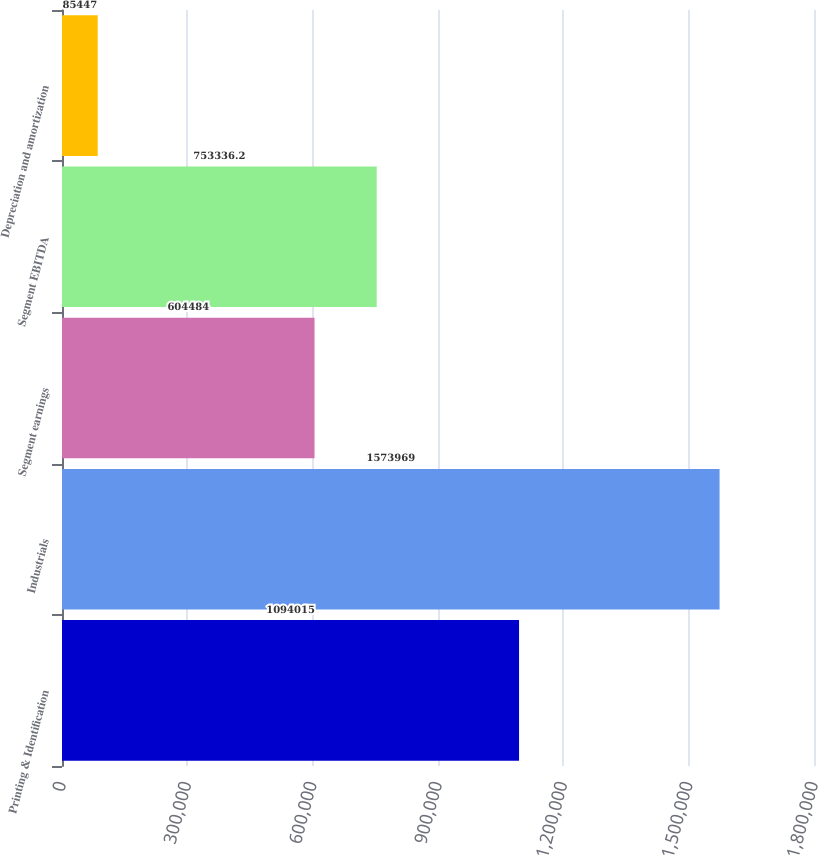Convert chart. <chart><loc_0><loc_0><loc_500><loc_500><bar_chart><fcel>Printing & Identification<fcel>Industrials<fcel>Segment earnings<fcel>Segment EBITDA<fcel>Depreciation and amortization<nl><fcel>1.09402e+06<fcel>1.57397e+06<fcel>604484<fcel>753336<fcel>85447<nl></chart> 